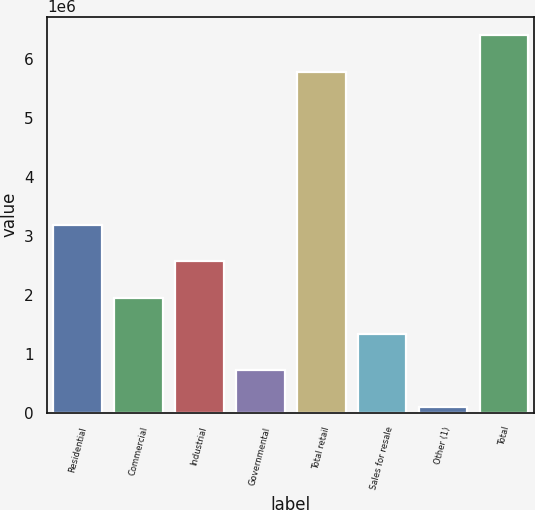Convert chart to OTSL. <chart><loc_0><loc_0><loc_500><loc_500><bar_chart><fcel>Residential<fcel>Commercial<fcel>Industrial<fcel>Governmental<fcel>Total retail<fcel>Sales for resale<fcel>Other (1)<fcel>Total<nl><fcel>3.18493e+06<fcel>1.95034e+06<fcel>2.56763e+06<fcel>715743<fcel>5.77512e+06<fcel>1.33304e+06<fcel>98446<fcel>6.39242e+06<nl></chart> 